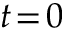Convert formula to latex. <formula><loc_0><loc_0><loc_500><loc_500>t \, = \, 0</formula> 